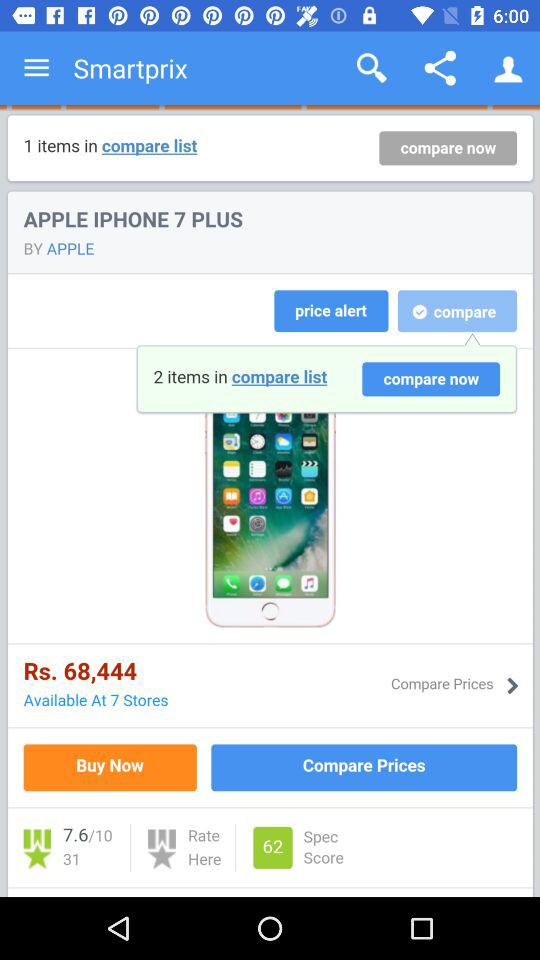How many ratings are given to the Apple iPhone 7 Plus? The rating is 7.6. 